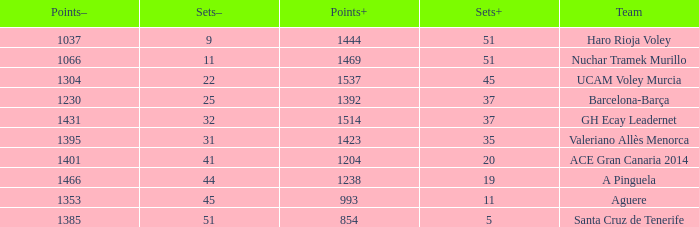What is the highest Points+ number that has a Sets+ number larger than 45, a Sets- number larger than 9, and a Points- number smaller than 1066? None. 